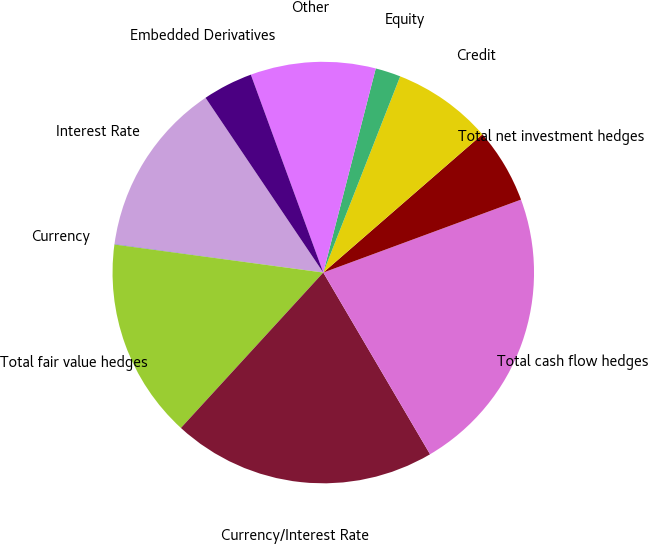Convert chart. <chart><loc_0><loc_0><loc_500><loc_500><pie_chart><fcel>Interest Rate<fcel>Currency<fcel>Total fair value hedges<fcel>Currency/Interest Rate<fcel>Total cash flow hedges<fcel>Total net investment hedges<fcel>Credit<fcel>Equity<fcel>Other<fcel>Embedded Derivatives<nl><fcel>13.41%<fcel>0.03%<fcel>15.32%<fcel>20.26%<fcel>22.17%<fcel>5.76%<fcel>7.67%<fcel>1.94%<fcel>9.59%<fcel>3.85%<nl></chart> 